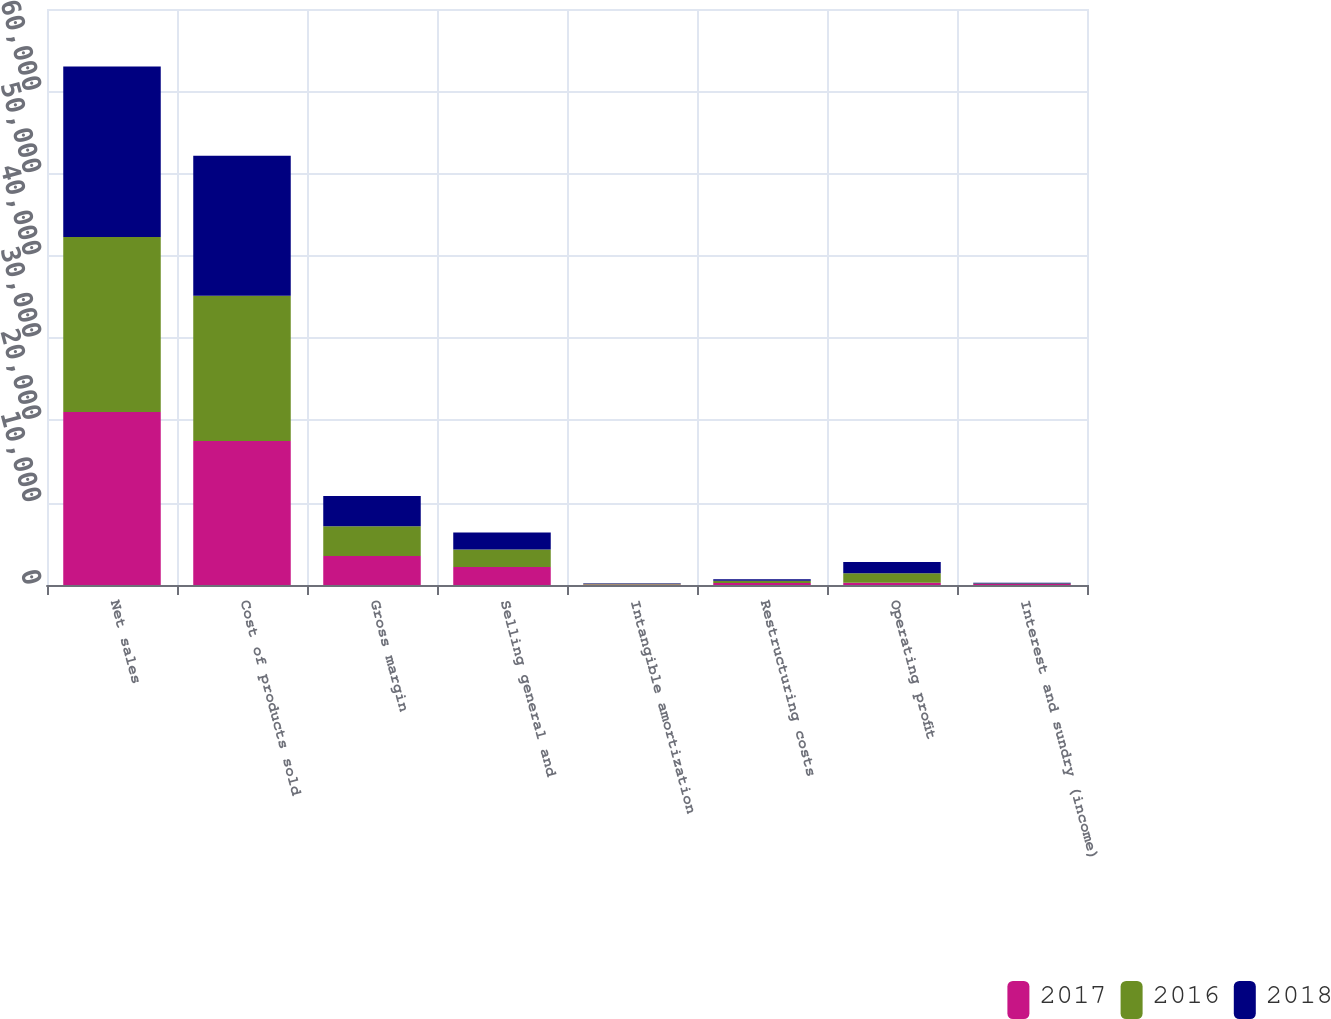<chart> <loc_0><loc_0><loc_500><loc_500><stacked_bar_chart><ecel><fcel>Net sales<fcel>Cost of products sold<fcel>Gross margin<fcel>Selling general and<fcel>Intangible amortization<fcel>Restructuring costs<fcel>Operating profit<fcel>Interest and sundry (income)<nl><fcel>2017<fcel>21037<fcel>17500<fcel>3537<fcel>2189<fcel>75<fcel>247<fcel>279<fcel>108<nl><fcel>2016<fcel>21253<fcel>17651<fcel>3602<fcel>2112<fcel>79<fcel>275<fcel>1136<fcel>87<nl><fcel>2018<fcel>20718<fcel>17026<fcel>3692<fcel>2080<fcel>71<fcel>173<fcel>1368<fcel>93<nl></chart> 